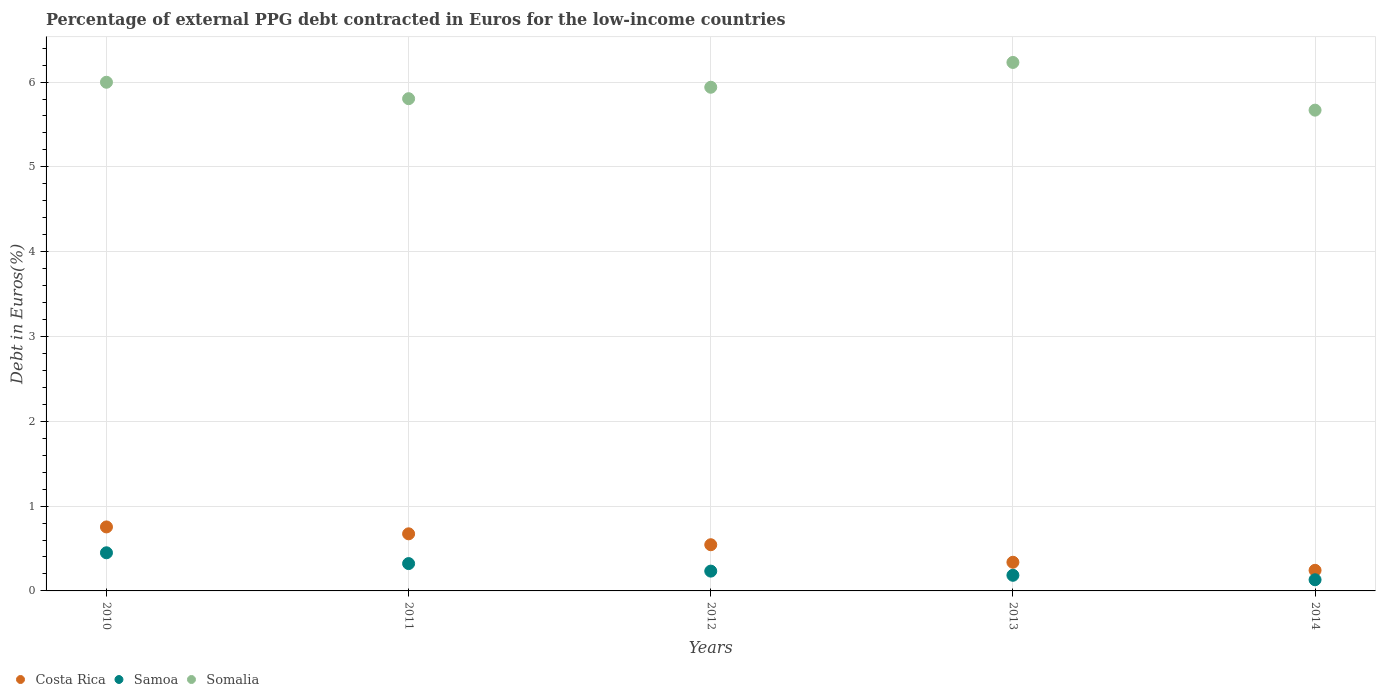How many different coloured dotlines are there?
Offer a terse response. 3. What is the percentage of external PPG debt contracted in Euros in Costa Rica in 2010?
Provide a short and direct response. 0.75. Across all years, what is the maximum percentage of external PPG debt contracted in Euros in Costa Rica?
Your answer should be compact. 0.75. Across all years, what is the minimum percentage of external PPG debt contracted in Euros in Samoa?
Provide a succinct answer. 0.13. In which year was the percentage of external PPG debt contracted in Euros in Somalia minimum?
Provide a short and direct response. 2014. What is the total percentage of external PPG debt contracted in Euros in Costa Rica in the graph?
Your answer should be compact. 2.55. What is the difference between the percentage of external PPG debt contracted in Euros in Somalia in 2010 and that in 2012?
Offer a terse response. 0.06. What is the difference between the percentage of external PPG debt contracted in Euros in Samoa in 2013 and the percentage of external PPG debt contracted in Euros in Somalia in 2014?
Offer a terse response. -5.48. What is the average percentage of external PPG debt contracted in Euros in Samoa per year?
Your response must be concise. 0.26. In the year 2011, what is the difference between the percentage of external PPG debt contracted in Euros in Somalia and percentage of external PPG debt contracted in Euros in Samoa?
Your response must be concise. 5.48. In how many years, is the percentage of external PPG debt contracted in Euros in Somalia greater than 4.6 %?
Your answer should be compact. 5. What is the ratio of the percentage of external PPG debt contracted in Euros in Samoa in 2011 to that in 2014?
Offer a terse response. 2.45. Is the percentage of external PPG debt contracted in Euros in Somalia in 2011 less than that in 2014?
Offer a very short reply. No. What is the difference between the highest and the second highest percentage of external PPG debt contracted in Euros in Costa Rica?
Your answer should be very brief. 0.08. What is the difference between the highest and the lowest percentage of external PPG debt contracted in Euros in Costa Rica?
Ensure brevity in your answer.  0.51. Is the sum of the percentage of external PPG debt contracted in Euros in Costa Rica in 2011 and 2014 greater than the maximum percentage of external PPG debt contracted in Euros in Samoa across all years?
Your answer should be compact. Yes. Is it the case that in every year, the sum of the percentage of external PPG debt contracted in Euros in Costa Rica and percentage of external PPG debt contracted in Euros in Somalia  is greater than the percentage of external PPG debt contracted in Euros in Samoa?
Keep it short and to the point. Yes. Does the percentage of external PPG debt contracted in Euros in Samoa monotonically increase over the years?
Your answer should be compact. No. Is the percentage of external PPG debt contracted in Euros in Somalia strictly greater than the percentage of external PPG debt contracted in Euros in Samoa over the years?
Provide a succinct answer. Yes. Is the percentage of external PPG debt contracted in Euros in Samoa strictly less than the percentage of external PPG debt contracted in Euros in Costa Rica over the years?
Offer a very short reply. Yes. How many years are there in the graph?
Your answer should be very brief. 5. Does the graph contain any zero values?
Offer a very short reply. No. How many legend labels are there?
Provide a short and direct response. 3. What is the title of the graph?
Your answer should be compact. Percentage of external PPG debt contracted in Euros for the low-income countries. What is the label or title of the X-axis?
Offer a very short reply. Years. What is the label or title of the Y-axis?
Your answer should be compact. Debt in Euros(%). What is the Debt in Euros(%) of Costa Rica in 2010?
Provide a short and direct response. 0.75. What is the Debt in Euros(%) in Samoa in 2010?
Ensure brevity in your answer.  0.45. What is the Debt in Euros(%) in Somalia in 2010?
Make the answer very short. 6. What is the Debt in Euros(%) in Costa Rica in 2011?
Ensure brevity in your answer.  0.67. What is the Debt in Euros(%) in Samoa in 2011?
Your answer should be very brief. 0.32. What is the Debt in Euros(%) of Somalia in 2011?
Provide a succinct answer. 5.8. What is the Debt in Euros(%) in Costa Rica in 2012?
Keep it short and to the point. 0.54. What is the Debt in Euros(%) of Samoa in 2012?
Make the answer very short. 0.23. What is the Debt in Euros(%) in Somalia in 2012?
Ensure brevity in your answer.  5.94. What is the Debt in Euros(%) of Costa Rica in 2013?
Your answer should be compact. 0.34. What is the Debt in Euros(%) in Samoa in 2013?
Give a very brief answer. 0.18. What is the Debt in Euros(%) in Somalia in 2013?
Your answer should be very brief. 6.23. What is the Debt in Euros(%) of Costa Rica in 2014?
Your response must be concise. 0.24. What is the Debt in Euros(%) in Samoa in 2014?
Keep it short and to the point. 0.13. What is the Debt in Euros(%) of Somalia in 2014?
Ensure brevity in your answer.  5.67. Across all years, what is the maximum Debt in Euros(%) in Costa Rica?
Offer a very short reply. 0.75. Across all years, what is the maximum Debt in Euros(%) of Samoa?
Ensure brevity in your answer.  0.45. Across all years, what is the maximum Debt in Euros(%) of Somalia?
Make the answer very short. 6.23. Across all years, what is the minimum Debt in Euros(%) of Costa Rica?
Make the answer very short. 0.24. Across all years, what is the minimum Debt in Euros(%) of Samoa?
Provide a short and direct response. 0.13. Across all years, what is the minimum Debt in Euros(%) of Somalia?
Your response must be concise. 5.67. What is the total Debt in Euros(%) in Costa Rica in the graph?
Ensure brevity in your answer.  2.55. What is the total Debt in Euros(%) of Samoa in the graph?
Your response must be concise. 1.32. What is the total Debt in Euros(%) in Somalia in the graph?
Keep it short and to the point. 29.64. What is the difference between the Debt in Euros(%) of Costa Rica in 2010 and that in 2011?
Provide a short and direct response. 0.08. What is the difference between the Debt in Euros(%) in Samoa in 2010 and that in 2011?
Provide a succinct answer. 0.13. What is the difference between the Debt in Euros(%) in Somalia in 2010 and that in 2011?
Your response must be concise. 0.19. What is the difference between the Debt in Euros(%) of Costa Rica in 2010 and that in 2012?
Your answer should be very brief. 0.21. What is the difference between the Debt in Euros(%) of Samoa in 2010 and that in 2012?
Your answer should be very brief. 0.22. What is the difference between the Debt in Euros(%) in Somalia in 2010 and that in 2012?
Offer a terse response. 0.06. What is the difference between the Debt in Euros(%) in Costa Rica in 2010 and that in 2013?
Offer a terse response. 0.42. What is the difference between the Debt in Euros(%) of Samoa in 2010 and that in 2013?
Your answer should be compact. 0.27. What is the difference between the Debt in Euros(%) of Somalia in 2010 and that in 2013?
Provide a short and direct response. -0.23. What is the difference between the Debt in Euros(%) of Costa Rica in 2010 and that in 2014?
Your answer should be very brief. 0.51. What is the difference between the Debt in Euros(%) of Samoa in 2010 and that in 2014?
Give a very brief answer. 0.32. What is the difference between the Debt in Euros(%) of Somalia in 2010 and that in 2014?
Your response must be concise. 0.33. What is the difference between the Debt in Euros(%) in Costa Rica in 2011 and that in 2012?
Offer a very short reply. 0.13. What is the difference between the Debt in Euros(%) of Samoa in 2011 and that in 2012?
Your answer should be very brief. 0.09. What is the difference between the Debt in Euros(%) of Somalia in 2011 and that in 2012?
Ensure brevity in your answer.  -0.13. What is the difference between the Debt in Euros(%) in Costa Rica in 2011 and that in 2013?
Keep it short and to the point. 0.34. What is the difference between the Debt in Euros(%) of Samoa in 2011 and that in 2013?
Offer a very short reply. 0.14. What is the difference between the Debt in Euros(%) of Somalia in 2011 and that in 2013?
Give a very brief answer. -0.43. What is the difference between the Debt in Euros(%) of Costa Rica in 2011 and that in 2014?
Offer a very short reply. 0.43. What is the difference between the Debt in Euros(%) of Samoa in 2011 and that in 2014?
Make the answer very short. 0.19. What is the difference between the Debt in Euros(%) of Somalia in 2011 and that in 2014?
Your answer should be compact. 0.14. What is the difference between the Debt in Euros(%) in Costa Rica in 2012 and that in 2013?
Provide a succinct answer. 0.21. What is the difference between the Debt in Euros(%) in Samoa in 2012 and that in 2013?
Ensure brevity in your answer.  0.05. What is the difference between the Debt in Euros(%) in Somalia in 2012 and that in 2013?
Make the answer very short. -0.29. What is the difference between the Debt in Euros(%) of Costa Rica in 2012 and that in 2014?
Keep it short and to the point. 0.3. What is the difference between the Debt in Euros(%) in Samoa in 2012 and that in 2014?
Your response must be concise. 0.1. What is the difference between the Debt in Euros(%) of Somalia in 2012 and that in 2014?
Make the answer very short. 0.27. What is the difference between the Debt in Euros(%) in Costa Rica in 2013 and that in 2014?
Provide a short and direct response. 0.1. What is the difference between the Debt in Euros(%) of Samoa in 2013 and that in 2014?
Make the answer very short. 0.05. What is the difference between the Debt in Euros(%) in Somalia in 2013 and that in 2014?
Provide a succinct answer. 0.56. What is the difference between the Debt in Euros(%) in Costa Rica in 2010 and the Debt in Euros(%) in Samoa in 2011?
Offer a terse response. 0.43. What is the difference between the Debt in Euros(%) in Costa Rica in 2010 and the Debt in Euros(%) in Somalia in 2011?
Keep it short and to the point. -5.05. What is the difference between the Debt in Euros(%) in Samoa in 2010 and the Debt in Euros(%) in Somalia in 2011?
Your answer should be very brief. -5.35. What is the difference between the Debt in Euros(%) in Costa Rica in 2010 and the Debt in Euros(%) in Samoa in 2012?
Your answer should be compact. 0.52. What is the difference between the Debt in Euros(%) of Costa Rica in 2010 and the Debt in Euros(%) of Somalia in 2012?
Your response must be concise. -5.18. What is the difference between the Debt in Euros(%) in Samoa in 2010 and the Debt in Euros(%) in Somalia in 2012?
Your answer should be very brief. -5.49. What is the difference between the Debt in Euros(%) in Costa Rica in 2010 and the Debt in Euros(%) in Samoa in 2013?
Your response must be concise. 0.57. What is the difference between the Debt in Euros(%) of Costa Rica in 2010 and the Debt in Euros(%) of Somalia in 2013?
Give a very brief answer. -5.48. What is the difference between the Debt in Euros(%) in Samoa in 2010 and the Debt in Euros(%) in Somalia in 2013?
Make the answer very short. -5.78. What is the difference between the Debt in Euros(%) in Costa Rica in 2010 and the Debt in Euros(%) in Samoa in 2014?
Keep it short and to the point. 0.62. What is the difference between the Debt in Euros(%) in Costa Rica in 2010 and the Debt in Euros(%) in Somalia in 2014?
Give a very brief answer. -4.91. What is the difference between the Debt in Euros(%) in Samoa in 2010 and the Debt in Euros(%) in Somalia in 2014?
Keep it short and to the point. -5.22. What is the difference between the Debt in Euros(%) in Costa Rica in 2011 and the Debt in Euros(%) in Samoa in 2012?
Your answer should be compact. 0.44. What is the difference between the Debt in Euros(%) in Costa Rica in 2011 and the Debt in Euros(%) in Somalia in 2012?
Your response must be concise. -5.27. What is the difference between the Debt in Euros(%) in Samoa in 2011 and the Debt in Euros(%) in Somalia in 2012?
Give a very brief answer. -5.62. What is the difference between the Debt in Euros(%) in Costa Rica in 2011 and the Debt in Euros(%) in Samoa in 2013?
Make the answer very short. 0.49. What is the difference between the Debt in Euros(%) in Costa Rica in 2011 and the Debt in Euros(%) in Somalia in 2013?
Keep it short and to the point. -5.56. What is the difference between the Debt in Euros(%) in Samoa in 2011 and the Debt in Euros(%) in Somalia in 2013?
Provide a short and direct response. -5.91. What is the difference between the Debt in Euros(%) of Costa Rica in 2011 and the Debt in Euros(%) of Samoa in 2014?
Offer a terse response. 0.54. What is the difference between the Debt in Euros(%) in Costa Rica in 2011 and the Debt in Euros(%) in Somalia in 2014?
Provide a succinct answer. -5. What is the difference between the Debt in Euros(%) of Samoa in 2011 and the Debt in Euros(%) of Somalia in 2014?
Keep it short and to the point. -5.35. What is the difference between the Debt in Euros(%) in Costa Rica in 2012 and the Debt in Euros(%) in Samoa in 2013?
Ensure brevity in your answer.  0.36. What is the difference between the Debt in Euros(%) in Costa Rica in 2012 and the Debt in Euros(%) in Somalia in 2013?
Offer a very short reply. -5.69. What is the difference between the Debt in Euros(%) of Samoa in 2012 and the Debt in Euros(%) of Somalia in 2013?
Provide a succinct answer. -6. What is the difference between the Debt in Euros(%) of Costa Rica in 2012 and the Debt in Euros(%) of Samoa in 2014?
Keep it short and to the point. 0.41. What is the difference between the Debt in Euros(%) in Costa Rica in 2012 and the Debt in Euros(%) in Somalia in 2014?
Offer a very short reply. -5.12. What is the difference between the Debt in Euros(%) in Samoa in 2012 and the Debt in Euros(%) in Somalia in 2014?
Ensure brevity in your answer.  -5.44. What is the difference between the Debt in Euros(%) in Costa Rica in 2013 and the Debt in Euros(%) in Samoa in 2014?
Keep it short and to the point. 0.21. What is the difference between the Debt in Euros(%) in Costa Rica in 2013 and the Debt in Euros(%) in Somalia in 2014?
Give a very brief answer. -5.33. What is the difference between the Debt in Euros(%) in Samoa in 2013 and the Debt in Euros(%) in Somalia in 2014?
Ensure brevity in your answer.  -5.48. What is the average Debt in Euros(%) in Costa Rica per year?
Your answer should be compact. 0.51. What is the average Debt in Euros(%) in Samoa per year?
Offer a terse response. 0.26. What is the average Debt in Euros(%) in Somalia per year?
Offer a very short reply. 5.93. In the year 2010, what is the difference between the Debt in Euros(%) of Costa Rica and Debt in Euros(%) of Samoa?
Offer a very short reply. 0.3. In the year 2010, what is the difference between the Debt in Euros(%) of Costa Rica and Debt in Euros(%) of Somalia?
Ensure brevity in your answer.  -5.24. In the year 2010, what is the difference between the Debt in Euros(%) in Samoa and Debt in Euros(%) in Somalia?
Offer a terse response. -5.55. In the year 2011, what is the difference between the Debt in Euros(%) in Costa Rica and Debt in Euros(%) in Samoa?
Provide a short and direct response. 0.35. In the year 2011, what is the difference between the Debt in Euros(%) of Costa Rica and Debt in Euros(%) of Somalia?
Your response must be concise. -5.13. In the year 2011, what is the difference between the Debt in Euros(%) in Samoa and Debt in Euros(%) in Somalia?
Your answer should be very brief. -5.48. In the year 2012, what is the difference between the Debt in Euros(%) in Costa Rica and Debt in Euros(%) in Samoa?
Your response must be concise. 0.31. In the year 2012, what is the difference between the Debt in Euros(%) of Costa Rica and Debt in Euros(%) of Somalia?
Keep it short and to the point. -5.39. In the year 2012, what is the difference between the Debt in Euros(%) in Samoa and Debt in Euros(%) in Somalia?
Offer a terse response. -5.71. In the year 2013, what is the difference between the Debt in Euros(%) in Costa Rica and Debt in Euros(%) in Samoa?
Give a very brief answer. 0.15. In the year 2013, what is the difference between the Debt in Euros(%) in Costa Rica and Debt in Euros(%) in Somalia?
Keep it short and to the point. -5.89. In the year 2013, what is the difference between the Debt in Euros(%) in Samoa and Debt in Euros(%) in Somalia?
Offer a terse response. -6.05. In the year 2014, what is the difference between the Debt in Euros(%) of Costa Rica and Debt in Euros(%) of Samoa?
Keep it short and to the point. 0.11. In the year 2014, what is the difference between the Debt in Euros(%) of Costa Rica and Debt in Euros(%) of Somalia?
Provide a succinct answer. -5.43. In the year 2014, what is the difference between the Debt in Euros(%) in Samoa and Debt in Euros(%) in Somalia?
Provide a succinct answer. -5.54. What is the ratio of the Debt in Euros(%) in Costa Rica in 2010 to that in 2011?
Your response must be concise. 1.12. What is the ratio of the Debt in Euros(%) of Samoa in 2010 to that in 2011?
Your answer should be compact. 1.39. What is the ratio of the Debt in Euros(%) in Somalia in 2010 to that in 2011?
Keep it short and to the point. 1.03. What is the ratio of the Debt in Euros(%) of Costa Rica in 2010 to that in 2012?
Make the answer very short. 1.39. What is the ratio of the Debt in Euros(%) in Samoa in 2010 to that in 2012?
Offer a terse response. 1.93. What is the ratio of the Debt in Euros(%) in Somalia in 2010 to that in 2012?
Your response must be concise. 1.01. What is the ratio of the Debt in Euros(%) of Costa Rica in 2010 to that in 2013?
Provide a short and direct response. 2.23. What is the ratio of the Debt in Euros(%) in Samoa in 2010 to that in 2013?
Provide a short and direct response. 2.44. What is the ratio of the Debt in Euros(%) of Somalia in 2010 to that in 2013?
Your answer should be very brief. 0.96. What is the ratio of the Debt in Euros(%) of Costa Rica in 2010 to that in 2014?
Offer a terse response. 3.1. What is the ratio of the Debt in Euros(%) in Samoa in 2010 to that in 2014?
Your response must be concise. 3.41. What is the ratio of the Debt in Euros(%) of Somalia in 2010 to that in 2014?
Offer a terse response. 1.06. What is the ratio of the Debt in Euros(%) in Costa Rica in 2011 to that in 2012?
Ensure brevity in your answer.  1.24. What is the ratio of the Debt in Euros(%) in Samoa in 2011 to that in 2012?
Your answer should be compact. 1.38. What is the ratio of the Debt in Euros(%) in Somalia in 2011 to that in 2012?
Provide a succinct answer. 0.98. What is the ratio of the Debt in Euros(%) of Costa Rica in 2011 to that in 2013?
Give a very brief answer. 1.99. What is the ratio of the Debt in Euros(%) in Samoa in 2011 to that in 2013?
Give a very brief answer. 1.75. What is the ratio of the Debt in Euros(%) in Somalia in 2011 to that in 2013?
Provide a short and direct response. 0.93. What is the ratio of the Debt in Euros(%) of Costa Rica in 2011 to that in 2014?
Your answer should be very brief. 2.77. What is the ratio of the Debt in Euros(%) in Samoa in 2011 to that in 2014?
Your answer should be very brief. 2.45. What is the ratio of the Debt in Euros(%) in Somalia in 2011 to that in 2014?
Make the answer very short. 1.02. What is the ratio of the Debt in Euros(%) in Costa Rica in 2012 to that in 2013?
Make the answer very short. 1.61. What is the ratio of the Debt in Euros(%) in Samoa in 2012 to that in 2013?
Keep it short and to the point. 1.27. What is the ratio of the Debt in Euros(%) in Somalia in 2012 to that in 2013?
Provide a short and direct response. 0.95. What is the ratio of the Debt in Euros(%) of Costa Rica in 2012 to that in 2014?
Provide a succinct answer. 2.24. What is the ratio of the Debt in Euros(%) of Samoa in 2012 to that in 2014?
Your answer should be compact. 1.77. What is the ratio of the Debt in Euros(%) in Somalia in 2012 to that in 2014?
Your response must be concise. 1.05. What is the ratio of the Debt in Euros(%) in Costa Rica in 2013 to that in 2014?
Your answer should be very brief. 1.39. What is the ratio of the Debt in Euros(%) of Samoa in 2013 to that in 2014?
Offer a terse response. 1.4. What is the ratio of the Debt in Euros(%) of Somalia in 2013 to that in 2014?
Give a very brief answer. 1.1. What is the difference between the highest and the second highest Debt in Euros(%) of Costa Rica?
Offer a terse response. 0.08. What is the difference between the highest and the second highest Debt in Euros(%) of Samoa?
Your answer should be compact. 0.13. What is the difference between the highest and the second highest Debt in Euros(%) of Somalia?
Provide a short and direct response. 0.23. What is the difference between the highest and the lowest Debt in Euros(%) of Costa Rica?
Make the answer very short. 0.51. What is the difference between the highest and the lowest Debt in Euros(%) of Samoa?
Make the answer very short. 0.32. What is the difference between the highest and the lowest Debt in Euros(%) of Somalia?
Give a very brief answer. 0.56. 